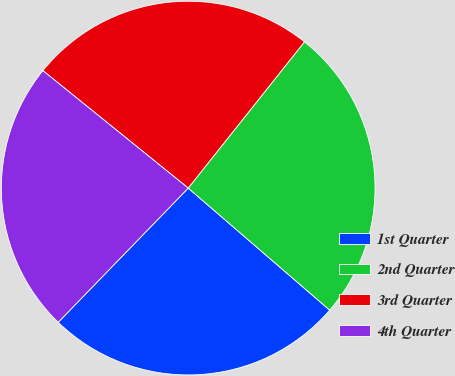Convert chart to OTSL. <chart><loc_0><loc_0><loc_500><loc_500><pie_chart><fcel>1st Quarter<fcel>2nd Quarter<fcel>3rd Quarter<fcel>4th Quarter<nl><fcel>25.92%<fcel>25.64%<fcel>24.87%<fcel>23.57%<nl></chart> 